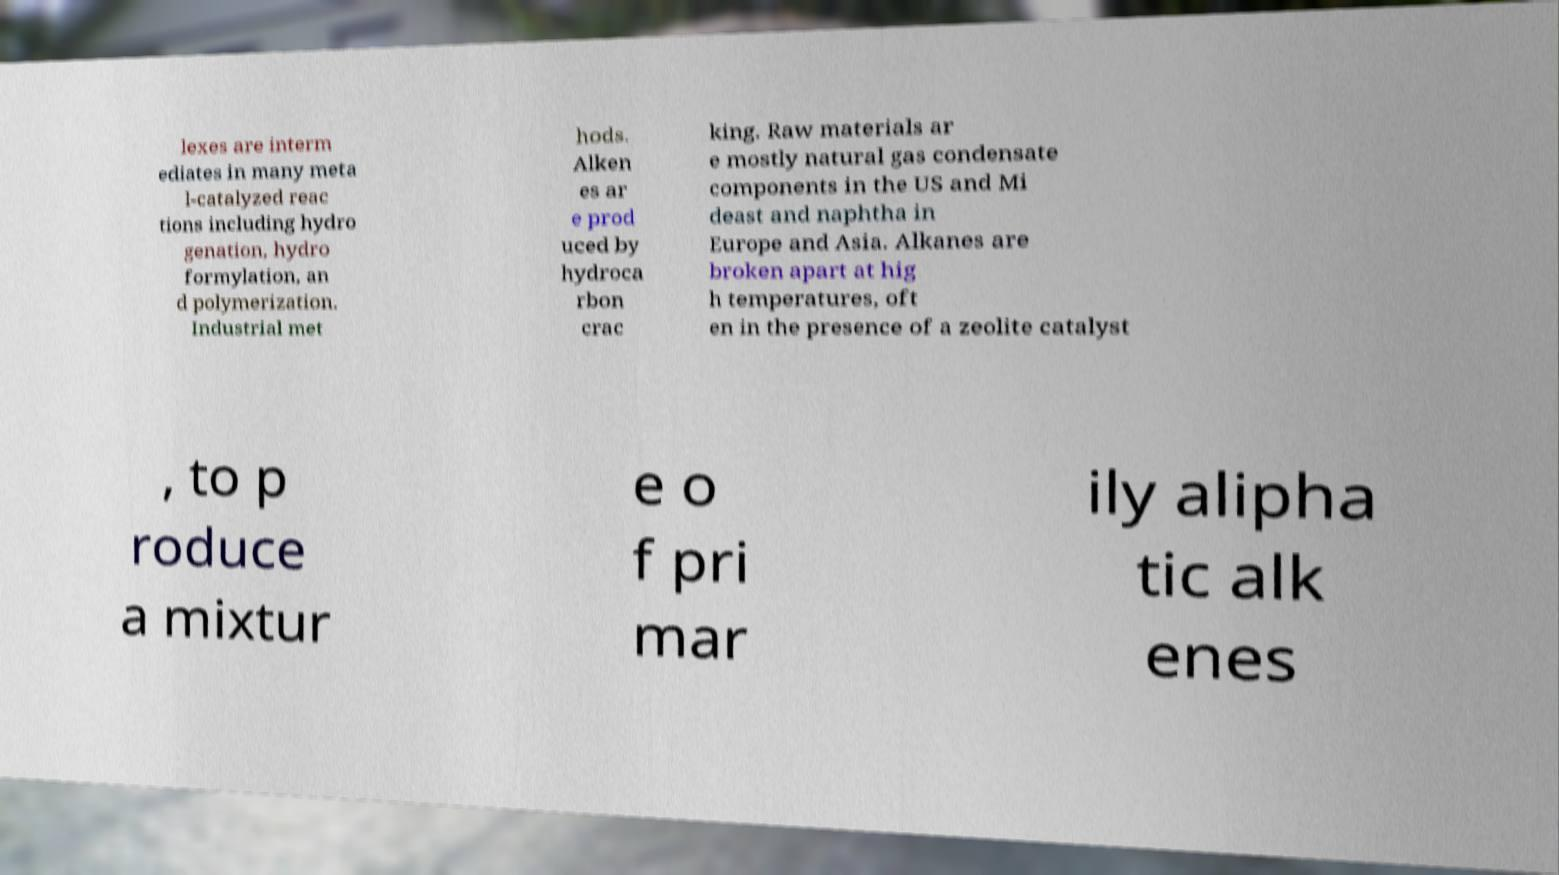For documentation purposes, I need the text within this image transcribed. Could you provide that? lexes are interm ediates in many meta l-catalyzed reac tions including hydro genation, hydro formylation, an d polymerization. Industrial met hods. Alken es ar e prod uced by hydroca rbon crac king. Raw materials ar e mostly natural gas condensate components in the US and Mi deast and naphtha in Europe and Asia. Alkanes are broken apart at hig h temperatures, oft en in the presence of a zeolite catalyst , to p roduce a mixtur e o f pri mar ily alipha tic alk enes 